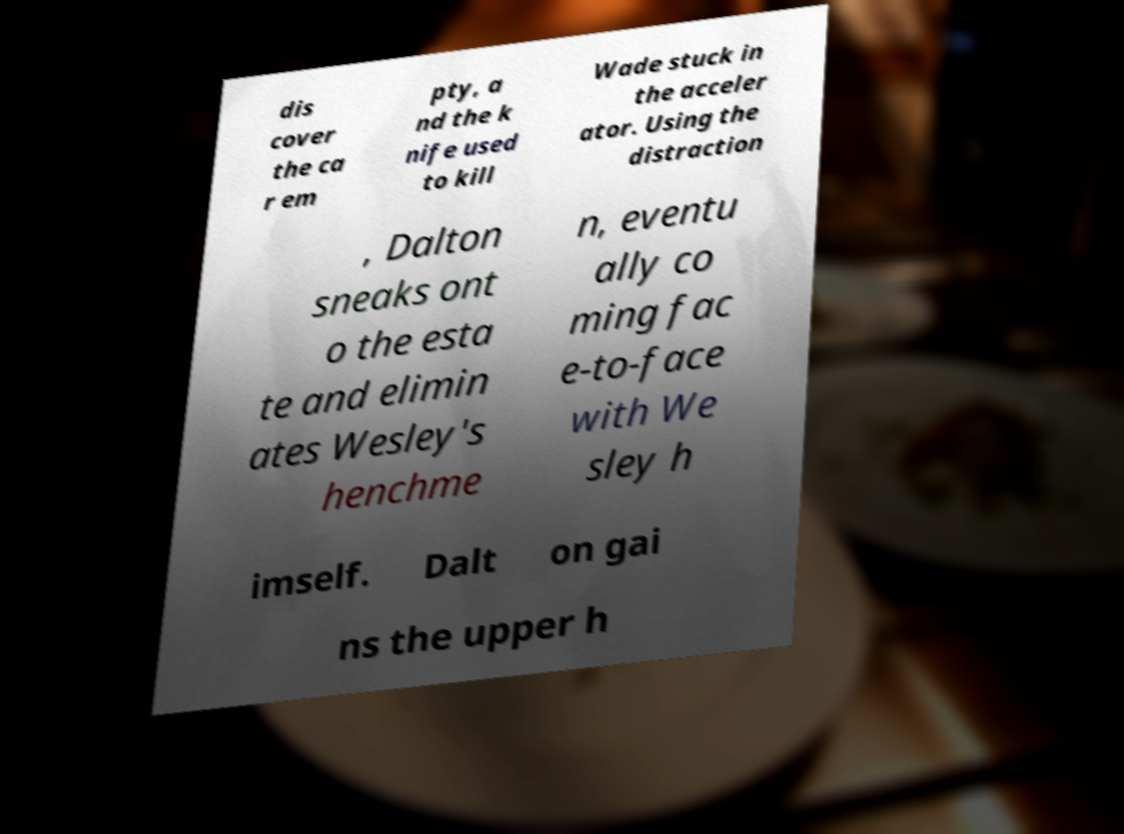What messages or text are displayed in this image? I need them in a readable, typed format. dis cover the ca r em pty, a nd the k nife used to kill Wade stuck in the acceler ator. Using the distraction , Dalton sneaks ont o the esta te and elimin ates Wesley's henchme n, eventu ally co ming fac e-to-face with We sley h imself. Dalt on gai ns the upper h 